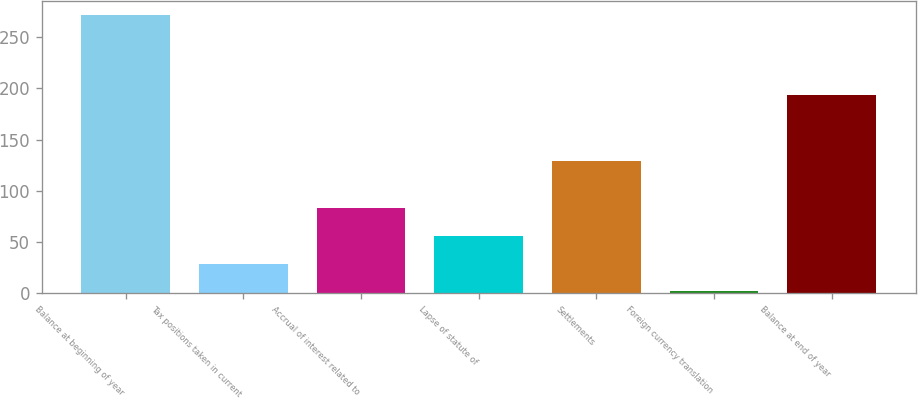<chart> <loc_0><loc_0><loc_500><loc_500><bar_chart><fcel>Balance at beginning of year<fcel>Tax positions taken in current<fcel>Accrual of interest related to<fcel>Lapse of statute of<fcel>Settlements<fcel>Foreign currency translation<fcel>Balance at end of year<nl><fcel>272<fcel>29<fcel>83<fcel>56<fcel>129<fcel>2<fcel>194<nl></chart> 